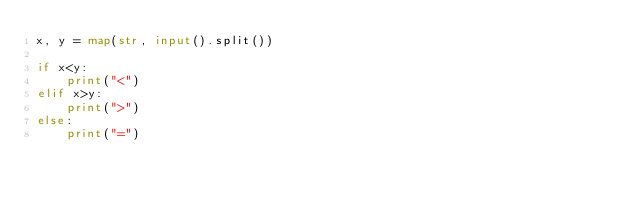Convert code to text. <code><loc_0><loc_0><loc_500><loc_500><_Python_>x, y = map(str, input().split())

if x<y:
    print("<")
elif x>y:
    print(">")
else:
    print("=")
</code> 